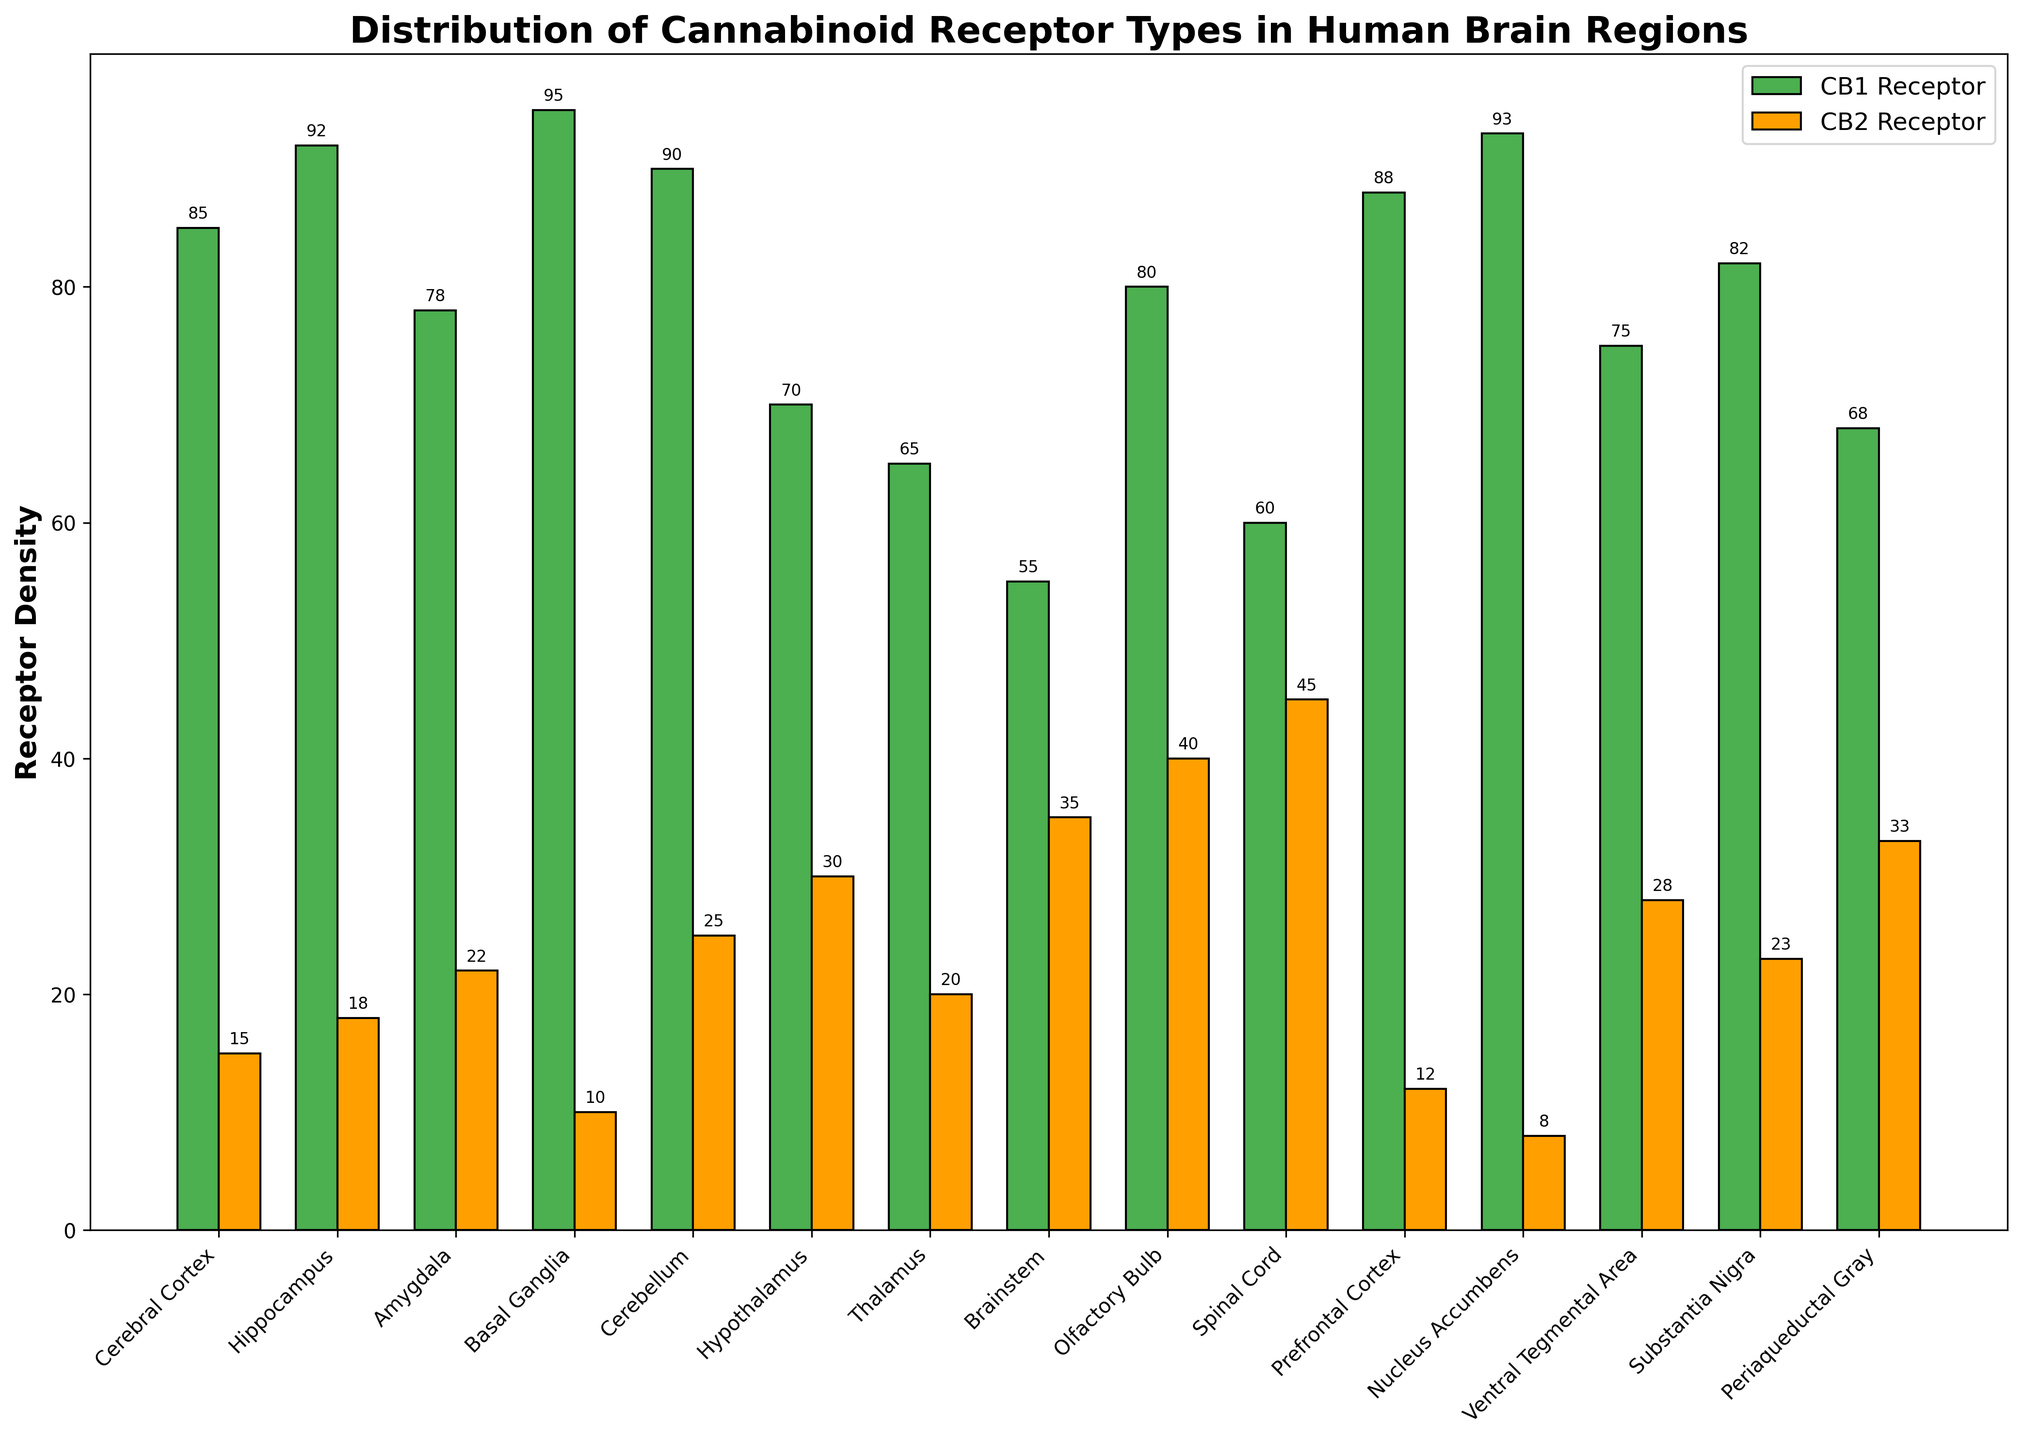what is the total density of CB1 and CB2 receptors in the prefrontal cortex? Add the density values of CB1 and CB2 receptors in the prefrontal cortex: 88 (CB1) + 12 (CB2) = 100.
Answer: 100 Which brain region has the highest CB2 receptor density? Compare the CB2 receptor densities across all brain regions; the spinal cord has the highest value of 45.
Answer: Spinal cord Which receptor type predominates in the olfactory bulb? Compare the densities of CB1 and CB2 receptors in the olfactory bulb; CB1 has a higher density of 80 compared to 40 for CB2.
Answer: CB1 Is the density of CB1 receptors in the nucleus accumbens greater than the density of CB2 receptors in the same region? Check the values for both receptor types in the nucleus accumbens: CB1 has a density of 93, and CB2 has a density of 8.
Answer: Yes Which two brain regions exhibit the closest CB1 receptor densities? Compare the CB1 densities across all regions and identify the two with the smallest difference: The cerebral cortex (85) and the amygdala (78) have a difference of 7.
Answer: Cerebral cortex and amygdala What is the average CB2 receptor density across the brain regions with more than 90 CB1 receptor density? Identify regions with CB1 density >90 (hippocampus, basal ganglia, prefrontal cortex, nucleus accumbens) and calculate the average CB2 density: (18 + 10 + 12 + 8) / 4 = 12.
Answer: 12 How many brain regions have CB1 receptor densities above 80? Count the number of brain regions with CB1 densities above 80: cerebral cortex, hippocampus, amygdala, basal ganglia, cerebellum, prefrontal cortex, nucleus accumbens, substantia nigra (8 regions).
Answer: 8 Is the sum of CB2 receptors in the hippocampus and the cerebellum greater than the sum in the brainstem and the thalamus? Calculate and compare the sums: hippocampus (18) + cerebellum (25) = 43; brainstem (35) + thalamus (20) = 55; 55 > 43.
Answer: No What is the difference in CB1 receptor density between the highest and lowest density regions? Identify the highest CB1 density (basal ganglia, 95) and the lowest (brainstem, 55), then subtract: 95 - 55 = 40.
Answer: 40 